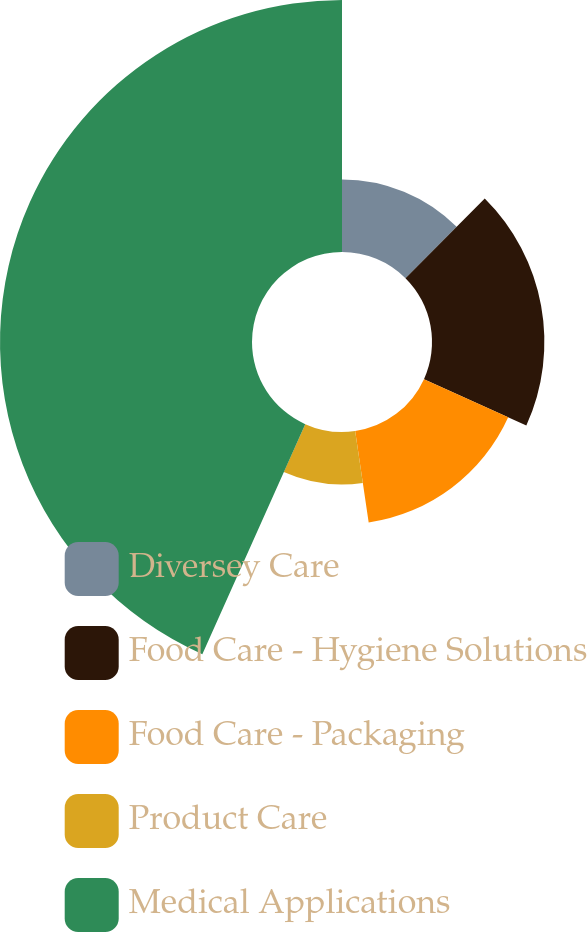Convert chart. <chart><loc_0><loc_0><loc_500><loc_500><pie_chart><fcel>Diversey Care<fcel>Food Care - Hygiene Solutions<fcel>Food Care - Packaging<fcel>Product Care<fcel>Medical Applications<nl><fcel>12.46%<fcel>19.31%<fcel>15.89%<fcel>9.03%<fcel>43.3%<nl></chart> 